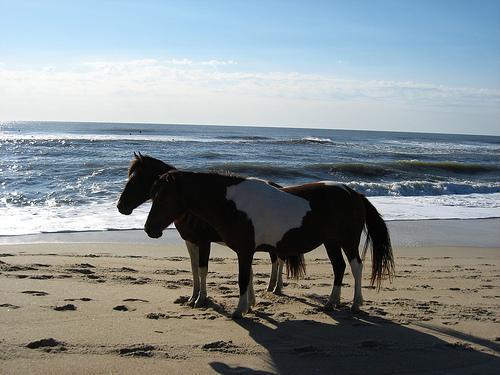How many horses are there?
Give a very brief answer. 2. 